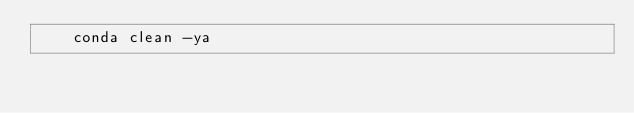Convert code to text. <code><loc_0><loc_0><loc_500><loc_500><_Dockerfile_>    conda clean -ya
</code> 